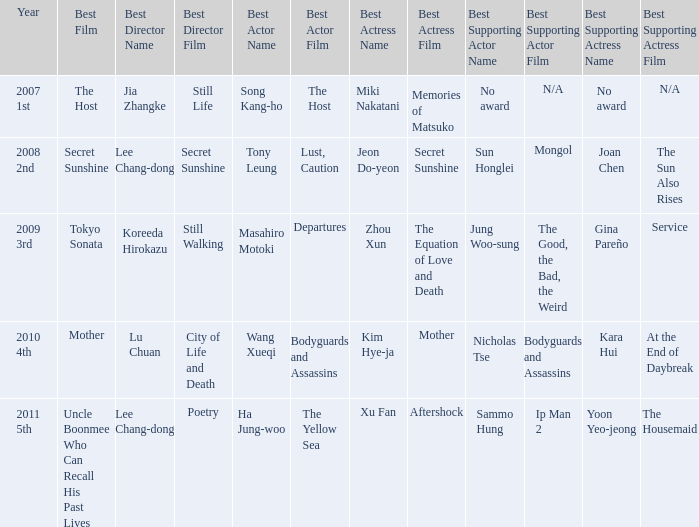Name the year for sammo hung for ip man 2 2011 5th. I'm looking to parse the entire table for insights. Could you assist me with that? {'header': ['Year', 'Best Film', 'Best Director Name', 'Best Director Film', 'Best Actor Name', 'Best Actor Film', 'Best Actress Name', 'Best Actress Film', 'Best Supporting Actor Name', 'Best Supporting Actor Film', 'Best Supporting Actress Name', 'Best Supporting Actress Film'], 'rows': [['2007 1st', 'The Host', 'Jia Zhangke', 'Still Life', 'Song Kang-ho', 'The Host', 'Miki Nakatani', 'Memories of Matsuko', 'No award', 'N/A', 'No award', 'N/A'], ['2008 2nd', 'Secret Sunshine', 'Lee Chang-dong', 'Secret Sunshine', 'Tony Leung', 'Lust, Caution', 'Jeon Do-yeon', 'Secret Sunshine', 'Sun Honglei', 'Mongol', 'Joan Chen', 'The Sun Also Rises'], ['2009 3rd', 'Tokyo Sonata', 'Koreeda Hirokazu', 'Still Walking', 'Masahiro Motoki', 'Departures', 'Zhou Xun', 'The Equation of Love and Death', 'Jung Woo-sung', 'The Good, the Bad, the Weird', 'Gina Pareño', 'Service'], ['2010 4th', 'Mother', 'Lu Chuan', 'City of Life and Death', 'Wang Xueqi', 'Bodyguards and Assassins', 'Kim Hye-ja', 'Mother', 'Nicholas Tse', 'Bodyguards and Assassins', 'Kara Hui', 'At the End of Daybreak'], ['2011 5th', 'Uncle Boonmee Who Can Recall His Past Lives', 'Lee Chang-dong', 'Poetry', 'Ha Jung-woo', 'The Yellow Sea', 'Xu Fan', 'Aftershock', 'Sammo Hung', 'Ip Man 2', 'Yoon Yeo-jeong', 'The Housemaid']]} 